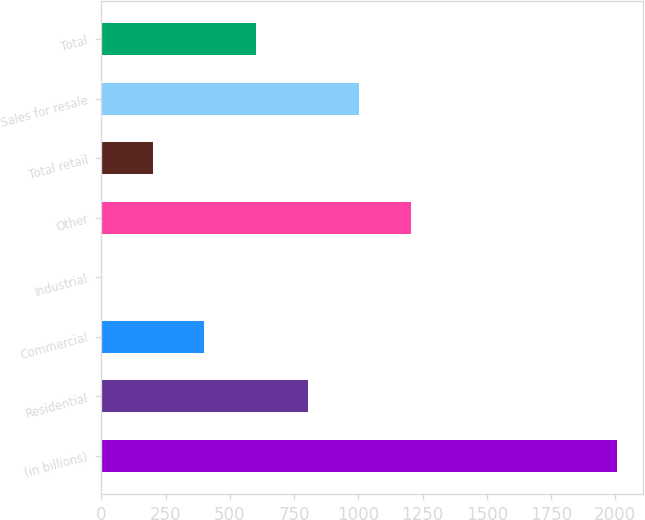Convert chart. <chart><loc_0><loc_0><loc_500><loc_500><bar_chart><fcel>(in billions)<fcel>Residential<fcel>Commercial<fcel>Industrial<fcel>Other<fcel>Total retail<fcel>Sales for resale<fcel>Total<nl><fcel>2006<fcel>802.52<fcel>401.36<fcel>0.2<fcel>1203.68<fcel>200.78<fcel>1003.1<fcel>601.94<nl></chart> 